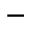Convert formula to latex. <formula><loc_0><loc_0><loc_500><loc_500>-</formula> 